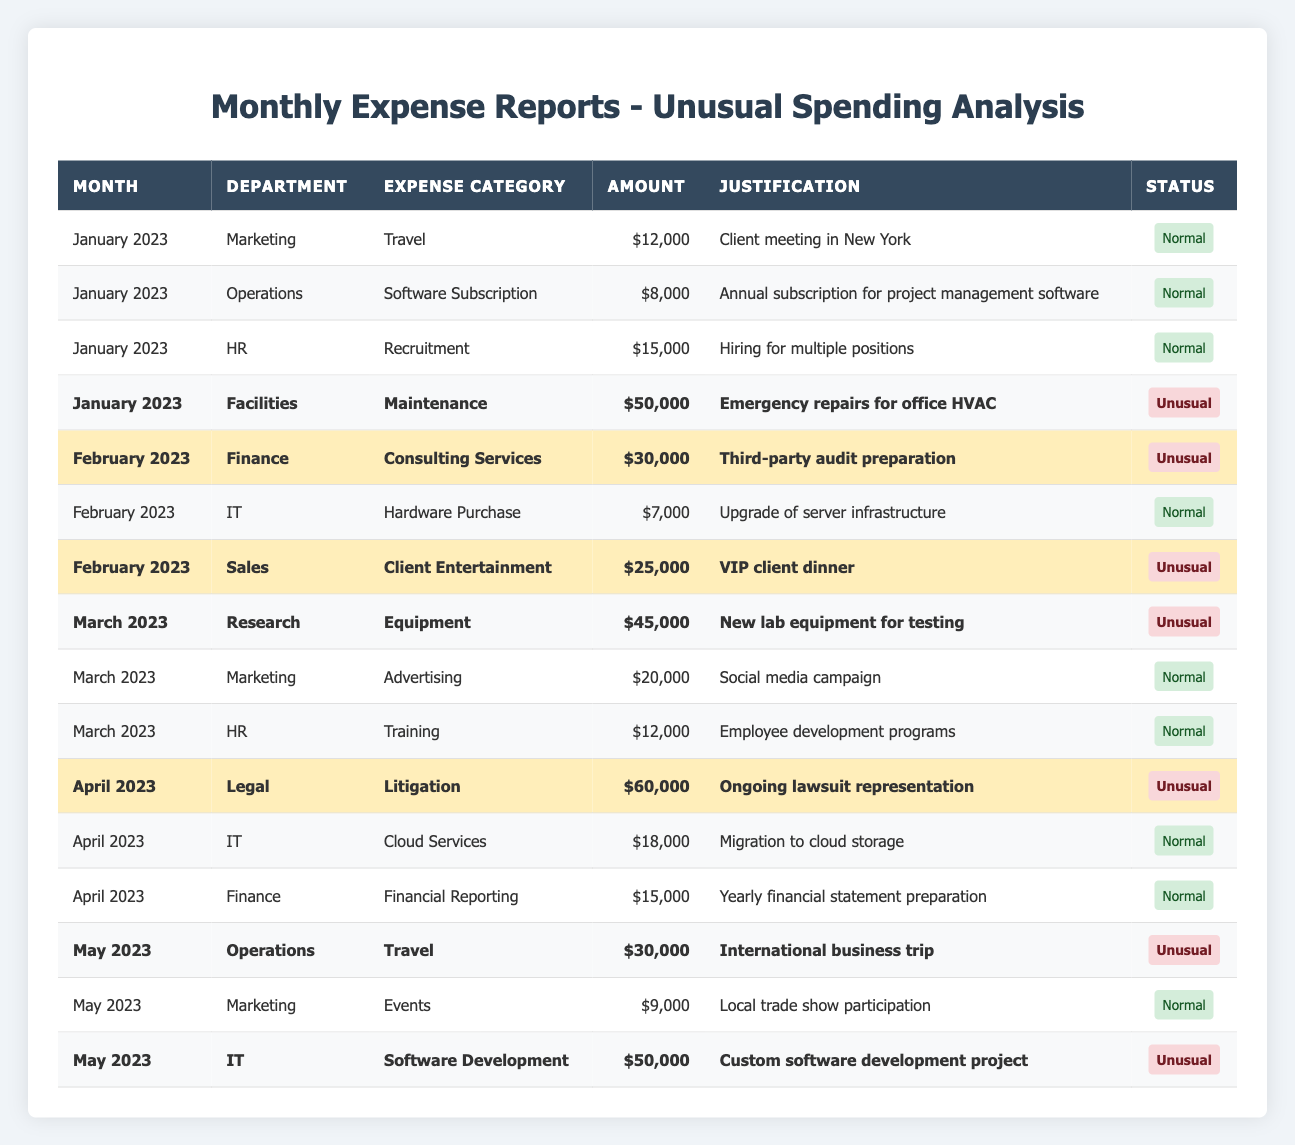What is the highest unusual expense recorded? The table indicates that the highest unusual expense is $60,000, which is from the Legal department for Litigation in April 2023.
Answer: $60,000 How many unusual expenses were recorded in February 2023? In February 2023, there are two unusual expenses: $30,000 for Consulting Services in the Finance department and $25,000 for Client Entertainment in the Sales department.
Answer: 2 What is the total amount spent on unusual expenses in January 2023? In January 2023, the only unusual expense is $50,000 for Maintenance in the Facilities department, making the total for unusual expenses in this month $50,000.
Answer: $50,000 Which department had the most unusual expenses across the months? The department with the most unusual expenses is the IT department, which has two entries with amounts of $50,000 in May and $7,000 in February.
Answer: IT department What is the average amount of unusual expenses for all months? The unusual expenses totaled $50,000 (January) + $30,000 (February) + $25,000 (February) + $45,000 (March) + $60,000 (April) + $30,000 (May) + $50,000 (May) = $290,000. There are 7 unusual expenses listed, so the average amount is $290,000 / 7 = $41,428.57.
Answer: $41,428.57 Did any month have more than one unusual expense recorded? Yes, February 2023 had two unusual expenses recorded: Consulting Services ($30,000) and Client Entertainment ($25,000), while May 2023 also had two: Operations Travel ($30,000) and IT Software Development ($50,000).
Answer: Yes What is the total amount spent on travel across all departments? The travel expenses recorded are $12,000 in January (Marketing) and $30,000 in May (Operations). So, the total travel expense is $12,000 + $30,000 = $42,000.
Answer: $42,000 Which category had the highest single expense recorded? The highest single expense recorded was $60,000 for Litigation in the Legal department during April 2023.
Answer: $60,000 Is there an unusual expense for the IT department in March 2023? No, there are no unusual expenses recorded for the IT department in March 2023; the only IT expense listed then is $7,000 for Hardware Purchase, which is normal.
Answer: No What is the total amount of unusual expenses for the month of May? In May 2023, the unusual expenses are $30,000 for Operations Travel and $50,000 for IT Software Development, totaling $30,000 + $50,000 = $80,000.
Answer: $80,000 